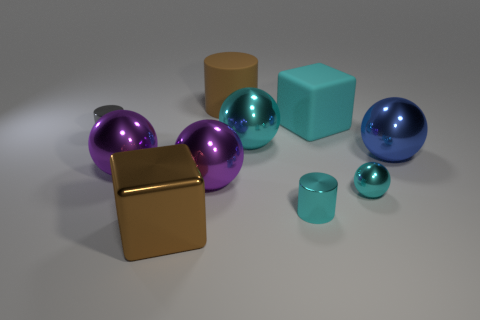Subtract all blue balls. How many balls are left? 4 Subtract all large blue metal balls. How many balls are left? 4 Subtract all red spheres. Subtract all purple cubes. How many spheres are left? 5 Subtract all blocks. How many objects are left? 8 Subtract all brown shiny cubes. Subtract all purple cylinders. How many objects are left? 9 Add 1 cyan things. How many cyan things are left? 5 Add 7 big cyan matte cubes. How many big cyan matte cubes exist? 8 Subtract 0 purple cubes. How many objects are left? 10 